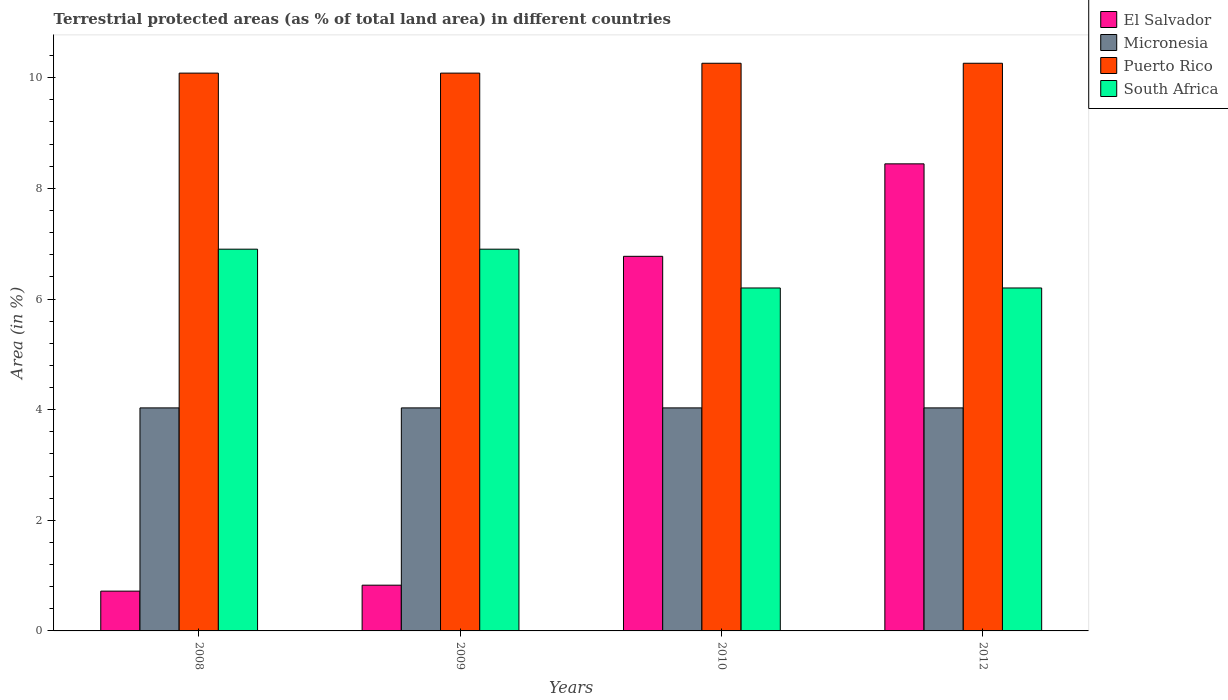How many different coloured bars are there?
Make the answer very short. 4. How many groups of bars are there?
Provide a short and direct response. 4. How many bars are there on the 2nd tick from the right?
Provide a short and direct response. 4. What is the percentage of terrestrial protected land in El Salvador in 2009?
Offer a very short reply. 0.83. Across all years, what is the maximum percentage of terrestrial protected land in Micronesia?
Give a very brief answer. 4.03. Across all years, what is the minimum percentage of terrestrial protected land in Puerto Rico?
Offer a terse response. 10.08. In which year was the percentage of terrestrial protected land in South Africa minimum?
Offer a terse response. 2010. What is the total percentage of terrestrial protected land in South Africa in the graph?
Provide a succinct answer. 26.2. What is the difference between the percentage of terrestrial protected land in Puerto Rico in 2009 and that in 2012?
Give a very brief answer. -0.18. What is the difference between the percentage of terrestrial protected land in Micronesia in 2008 and the percentage of terrestrial protected land in South Africa in 2009?
Provide a short and direct response. -2.87. What is the average percentage of terrestrial protected land in Puerto Rico per year?
Ensure brevity in your answer.  10.17. In the year 2010, what is the difference between the percentage of terrestrial protected land in El Salvador and percentage of terrestrial protected land in Puerto Rico?
Provide a short and direct response. -3.49. In how many years, is the percentage of terrestrial protected land in Micronesia greater than 3.2 %?
Keep it short and to the point. 4. What is the ratio of the percentage of terrestrial protected land in South Africa in 2008 to that in 2009?
Offer a very short reply. 1. Is the percentage of terrestrial protected land in Micronesia in 2009 less than that in 2010?
Your answer should be very brief. No. What is the difference between the highest and the second highest percentage of terrestrial protected land in Micronesia?
Offer a terse response. 0. What is the difference between the highest and the lowest percentage of terrestrial protected land in Puerto Rico?
Provide a succinct answer. 0.18. In how many years, is the percentage of terrestrial protected land in El Salvador greater than the average percentage of terrestrial protected land in El Salvador taken over all years?
Ensure brevity in your answer.  2. Is it the case that in every year, the sum of the percentage of terrestrial protected land in Puerto Rico and percentage of terrestrial protected land in El Salvador is greater than the sum of percentage of terrestrial protected land in South Africa and percentage of terrestrial protected land in Micronesia?
Keep it short and to the point. No. What does the 4th bar from the left in 2010 represents?
Offer a very short reply. South Africa. What does the 1st bar from the right in 2009 represents?
Give a very brief answer. South Africa. Is it the case that in every year, the sum of the percentage of terrestrial protected land in Puerto Rico and percentage of terrestrial protected land in Micronesia is greater than the percentage of terrestrial protected land in El Salvador?
Offer a very short reply. Yes. How many bars are there?
Ensure brevity in your answer.  16. Are all the bars in the graph horizontal?
Ensure brevity in your answer.  No. Are the values on the major ticks of Y-axis written in scientific E-notation?
Offer a terse response. No. How are the legend labels stacked?
Give a very brief answer. Vertical. What is the title of the graph?
Ensure brevity in your answer.  Terrestrial protected areas (as % of total land area) in different countries. What is the label or title of the Y-axis?
Provide a succinct answer. Area (in %). What is the Area (in %) of El Salvador in 2008?
Give a very brief answer. 0.72. What is the Area (in %) in Micronesia in 2008?
Your answer should be compact. 4.03. What is the Area (in %) in Puerto Rico in 2008?
Make the answer very short. 10.08. What is the Area (in %) in South Africa in 2008?
Offer a very short reply. 6.9. What is the Area (in %) of El Salvador in 2009?
Your answer should be compact. 0.83. What is the Area (in %) of Micronesia in 2009?
Your answer should be very brief. 4.03. What is the Area (in %) in Puerto Rico in 2009?
Your answer should be very brief. 10.08. What is the Area (in %) in South Africa in 2009?
Provide a short and direct response. 6.9. What is the Area (in %) of El Salvador in 2010?
Keep it short and to the point. 6.77. What is the Area (in %) of Micronesia in 2010?
Provide a succinct answer. 4.03. What is the Area (in %) in Puerto Rico in 2010?
Give a very brief answer. 10.26. What is the Area (in %) of South Africa in 2010?
Your answer should be very brief. 6.2. What is the Area (in %) in El Salvador in 2012?
Make the answer very short. 8.44. What is the Area (in %) of Micronesia in 2012?
Give a very brief answer. 4.03. What is the Area (in %) in Puerto Rico in 2012?
Ensure brevity in your answer.  10.26. What is the Area (in %) of South Africa in 2012?
Your response must be concise. 6.2. Across all years, what is the maximum Area (in %) of El Salvador?
Make the answer very short. 8.44. Across all years, what is the maximum Area (in %) in Micronesia?
Give a very brief answer. 4.03. Across all years, what is the maximum Area (in %) in Puerto Rico?
Give a very brief answer. 10.26. Across all years, what is the maximum Area (in %) of South Africa?
Your answer should be compact. 6.9. Across all years, what is the minimum Area (in %) in El Salvador?
Your response must be concise. 0.72. Across all years, what is the minimum Area (in %) of Micronesia?
Offer a very short reply. 4.03. Across all years, what is the minimum Area (in %) in Puerto Rico?
Keep it short and to the point. 10.08. Across all years, what is the minimum Area (in %) in South Africa?
Keep it short and to the point. 6.2. What is the total Area (in %) in El Salvador in the graph?
Offer a terse response. 16.76. What is the total Area (in %) of Micronesia in the graph?
Keep it short and to the point. 16.13. What is the total Area (in %) in Puerto Rico in the graph?
Your answer should be compact. 40.69. What is the total Area (in %) of South Africa in the graph?
Your answer should be very brief. 26.2. What is the difference between the Area (in %) of El Salvador in 2008 and that in 2009?
Provide a succinct answer. -0.11. What is the difference between the Area (in %) in Puerto Rico in 2008 and that in 2009?
Provide a short and direct response. 0. What is the difference between the Area (in %) in El Salvador in 2008 and that in 2010?
Your answer should be very brief. -6.05. What is the difference between the Area (in %) of Micronesia in 2008 and that in 2010?
Ensure brevity in your answer.  0. What is the difference between the Area (in %) in Puerto Rico in 2008 and that in 2010?
Offer a very short reply. -0.18. What is the difference between the Area (in %) in South Africa in 2008 and that in 2010?
Offer a very short reply. 0.7. What is the difference between the Area (in %) in El Salvador in 2008 and that in 2012?
Make the answer very short. -7.72. What is the difference between the Area (in %) in Micronesia in 2008 and that in 2012?
Offer a terse response. 0. What is the difference between the Area (in %) in Puerto Rico in 2008 and that in 2012?
Provide a succinct answer. -0.18. What is the difference between the Area (in %) of South Africa in 2008 and that in 2012?
Keep it short and to the point. 0.7. What is the difference between the Area (in %) in El Salvador in 2009 and that in 2010?
Your response must be concise. -5.95. What is the difference between the Area (in %) in Puerto Rico in 2009 and that in 2010?
Your response must be concise. -0.18. What is the difference between the Area (in %) in South Africa in 2009 and that in 2010?
Keep it short and to the point. 0.7. What is the difference between the Area (in %) of El Salvador in 2009 and that in 2012?
Offer a very short reply. -7.62. What is the difference between the Area (in %) of Puerto Rico in 2009 and that in 2012?
Ensure brevity in your answer.  -0.18. What is the difference between the Area (in %) of South Africa in 2009 and that in 2012?
Your answer should be compact. 0.7. What is the difference between the Area (in %) in El Salvador in 2010 and that in 2012?
Offer a very short reply. -1.67. What is the difference between the Area (in %) of Puerto Rico in 2010 and that in 2012?
Your answer should be compact. -0. What is the difference between the Area (in %) of South Africa in 2010 and that in 2012?
Keep it short and to the point. 0. What is the difference between the Area (in %) of El Salvador in 2008 and the Area (in %) of Micronesia in 2009?
Your answer should be compact. -3.31. What is the difference between the Area (in %) of El Salvador in 2008 and the Area (in %) of Puerto Rico in 2009?
Provide a succinct answer. -9.36. What is the difference between the Area (in %) of El Salvador in 2008 and the Area (in %) of South Africa in 2009?
Your answer should be compact. -6.18. What is the difference between the Area (in %) in Micronesia in 2008 and the Area (in %) in Puerto Rico in 2009?
Your response must be concise. -6.05. What is the difference between the Area (in %) in Micronesia in 2008 and the Area (in %) in South Africa in 2009?
Make the answer very short. -2.87. What is the difference between the Area (in %) of Puerto Rico in 2008 and the Area (in %) of South Africa in 2009?
Offer a very short reply. 3.18. What is the difference between the Area (in %) in El Salvador in 2008 and the Area (in %) in Micronesia in 2010?
Ensure brevity in your answer.  -3.31. What is the difference between the Area (in %) in El Salvador in 2008 and the Area (in %) in Puerto Rico in 2010?
Make the answer very short. -9.54. What is the difference between the Area (in %) in El Salvador in 2008 and the Area (in %) in South Africa in 2010?
Offer a very short reply. -5.48. What is the difference between the Area (in %) in Micronesia in 2008 and the Area (in %) in Puerto Rico in 2010?
Offer a terse response. -6.23. What is the difference between the Area (in %) in Micronesia in 2008 and the Area (in %) in South Africa in 2010?
Offer a terse response. -2.17. What is the difference between the Area (in %) of Puerto Rico in 2008 and the Area (in %) of South Africa in 2010?
Your answer should be compact. 3.88. What is the difference between the Area (in %) in El Salvador in 2008 and the Area (in %) in Micronesia in 2012?
Provide a succinct answer. -3.31. What is the difference between the Area (in %) in El Salvador in 2008 and the Area (in %) in Puerto Rico in 2012?
Your answer should be compact. -9.54. What is the difference between the Area (in %) of El Salvador in 2008 and the Area (in %) of South Africa in 2012?
Offer a very short reply. -5.48. What is the difference between the Area (in %) in Micronesia in 2008 and the Area (in %) in Puerto Rico in 2012?
Your answer should be compact. -6.23. What is the difference between the Area (in %) in Micronesia in 2008 and the Area (in %) in South Africa in 2012?
Provide a short and direct response. -2.17. What is the difference between the Area (in %) of Puerto Rico in 2008 and the Area (in %) of South Africa in 2012?
Provide a succinct answer. 3.88. What is the difference between the Area (in %) in El Salvador in 2009 and the Area (in %) in Micronesia in 2010?
Your response must be concise. -3.2. What is the difference between the Area (in %) of El Salvador in 2009 and the Area (in %) of Puerto Rico in 2010?
Offer a terse response. -9.44. What is the difference between the Area (in %) of El Salvador in 2009 and the Area (in %) of South Africa in 2010?
Keep it short and to the point. -5.37. What is the difference between the Area (in %) of Micronesia in 2009 and the Area (in %) of Puerto Rico in 2010?
Offer a very short reply. -6.23. What is the difference between the Area (in %) of Micronesia in 2009 and the Area (in %) of South Africa in 2010?
Offer a very short reply. -2.17. What is the difference between the Area (in %) of Puerto Rico in 2009 and the Area (in %) of South Africa in 2010?
Your answer should be very brief. 3.88. What is the difference between the Area (in %) in El Salvador in 2009 and the Area (in %) in Micronesia in 2012?
Make the answer very short. -3.2. What is the difference between the Area (in %) of El Salvador in 2009 and the Area (in %) of Puerto Rico in 2012?
Give a very brief answer. -9.44. What is the difference between the Area (in %) of El Salvador in 2009 and the Area (in %) of South Africa in 2012?
Give a very brief answer. -5.37. What is the difference between the Area (in %) in Micronesia in 2009 and the Area (in %) in Puerto Rico in 2012?
Make the answer very short. -6.23. What is the difference between the Area (in %) in Micronesia in 2009 and the Area (in %) in South Africa in 2012?
Keep it short and to the point. -2.17. What is the difference between the Area (in %) of Puerto Rico in 2009 and the Area (in %) of South Africa in 2012?
Make the answer very short. 3.88. What is the difference between the Area (in %) in El Salvador in 2010 and the Area (in %) in Micronesia in 2012?
Your answer should be compact. 2.74. What is the difference between the Area (in %) of El Salvador in 2010 and the Area (in %) of Puerto Rico in 2012?
Your answer should be compact. -3.49. What is the difference between the Area (in %) in El Salvador in 2010 and the Area (in %) in South Africa in 2012?
Make the answer very short. 0.57. What is the difference between the Area (in %) of Micronesia in 2010 and the Area (in %) of Puerto Rico in 2012?
Provide a short and direct response. -6.23. What is the difference between the Area (in %) of Micronesia in 2010 and the Area (in %) of South Africa in 2012?
Make the answer very short. -2.17. What is the difference between the Area (in %) of Puerto Rico in 2010 and the Area (in %) of South Africa in 2012?
Offer a terse response. 4.06. What is the average Area (in %) in El Salvador per year?
Offer a terse response. 4.19. What is the average Area (in %) in Micronesia per year?
Make the answer very short. 4.03. What is the average Area (in %) of Puerto Rico per year?
Provide a short and direct response. 10.17. What is the average Area (in %) in South Africa per year?
Give a very brief answer. 6.55. In the year 2008, what is the difference between the Area (in %) in El Salvador and Area (in %) in Micronesia?
Your response must be concise. -3.31. In the year 2008, what is the difference between the Area (in %) of El Salvador and Area (in %) of Puerto Rico?
Ensure brevity in your answer.  -9.36. In the year 2008, what is the difference between the Area (in %) in El Salvador and Area (in %) in South Africa?
Offer a very short reply. -6.18. In the year 2008, what is the difference between the Area (in %) of Micronesia and Area (in %) of Puerto Rico?
Your answer should be very brief. -6.05. In the year 2008, what is the difference between the Area (in %) in Micronesia and Area (in %) in South Africa?
Your answer should be very brief. -2.87. In the year 2008, what is the difference between the Area (in %) in Puerto Rico and Area (in %) in South Africa?
Keep it short and to the point. 3.18. In the year 2009, what is the difference between the Area (in %) of El Salvador and Area (in %) of Micronesia?
Your answer should be compact. -3.2. In the year 2009, what is the difference between the Area (in %) in El Salvador and Area (in %) in Puerto Rico?
Your answer should be very brief. -9.26. In the year 2009, what is the difference between the Area (in %) in El Salvador and Area (in %) in South Africa?
Give a very brief answer. -6.07. In the year 2009, what is the difference between the Area (in %) of Micronesia and Area (in %) of Puerto Rico?
Provide a succinct answer. -6.05. In the year 2009, what is the difference between the Area (in %) of Micronesia and Area (in %) of South Africa?
Ensure brevity in your answer.  -2.87. In the year 2009, what is the difference between the Area (in %) in Puerto Rico and Area (in %) in South Africa?
Your answer should be very brief. 3.18. In the year 2010, what is the difference between the Area (in %) in El Salvador and Area (in %) in Micronesia?
Your answer should be compact. 2.74. In the year 2010, what is the difference between the Area (in %) in El Salvador and Area (in %) in Puerto Rico?
Give a very brief answer. -3.49. In the year 2010, what is the difference between the Area (in %) in El Salvador and Area (in %) in South Africa?
Provide a short and direct response. 0.57. In the year 2010, what is the difference between the Area (in %) of Micronesia and Area (in %) of Puerto Rico?
Your answer should be compact. -6.23. In the year 2010, what is the difference between the Area (in %) of Micronesia and Area (in %) of South Africa?
Make the answer very short. -2.17. In the year 2010, what is the difference between the Area (in %) in Puerto Rico and Area (in %) in South Africa?
Keep it short and to the point. 4.06. In the year 2012, what is the difference between the Area (in %) in El Salvador and Area (in %) in Micronesia?
Give a very brief answer. 4.41. In the year 2012, what is the difference between the Area (in %) in El Salvador and Area (in %) in Puerto Rico?
Your response must be concise. -1.82. In the year 2012, what is the difference between the Area (in %) of El Salvador and Area (in %) of South Africa?
Keep it short and to the point. 2.24. In the year 2012, what is the difference between the Area (in %) of Micronesia and Area (in %) of Puerto Rico?
Offer a very short reply. -6.23. In the year 2012, what is the difference between the Area (in %) of Micronesia and Area (in %) of South Africa?
Make the answer very short. -2.17. In the year 2012, what is the difference between the Area (in %) in Puerto Rico and Area (in %) in South Africa?
Ensure brevity in your answer.  4.06. What is the ratio of the Area (in %) in El Salvador in 2008 to that in 2009?
Provide a short and direct response. 0.87. What is the ratio of the Area (in %) of Micronesia in 2008 to that in 2009?
Keep it short and to the point. 1. What is the ratio of the Area (in %) of Puerto Rico in 2008 to that in 2009?
Give a very brief answer. 1. What is the ratio of the Area (in %) in El Salvador in 2008 to that in 2010?
Your answer should be very brief. 0.11. What is the ratio of the Area (in %) in Micronesia in 2008 to that in 2010?
Offer a very short reply. 1. What is the ratio of the Area (in %) of Puerto Rico in 2008 to that in 2010?
Provide a succinct answer. 0.98. What is the ratio of the Area (in %) of South Africa in 2008 to that in 2010?
Your answer should be very brief. 1.11. What is the ratio of the Area (in %) of El Salvador in 2008 to that in 2012?
Offer a very short reply. 0.09. What is the ratio of the Area (in %) in Micronesia in 2008 to that in 2012?
Provide a succinct answer. 1. What is the ratio of the Area (in %) in Puerto Rico in 2008 to that in 2012?
Your answer should be compact. 0.98. What is the ratio of the Area (in %) of South Africa in 2008 to that in 2012?
Provide a succinct answer. 1.11. What is the ratio of the Area (in %) of El Salvador in 2009 to that in 2010?
Keep it short and to the point. 0.12. What is the ratio of the Area (in %) of Puerto Rico in 2009 to that in 2010?
Give a very brief answer. 0.98. What is the ratio of the Area (in %) of South Africa in 2009 to that in 2010?
Your answer should be compact. 1.11. What is the ratio of the Area (in %) of El Salvador in 2009 to that in 2012?
Your answer should be very brief. 0.1. What is the ratio of the Area (in %) of Micronesia in 2009 to that in 2012?
Keep it short and to the point. 1. What is the ratio of the Area (in %) of Puerto Rico in 2009 to that in 2012?
Keep it short and to the point. 0.98. What is the ratio of the Area (in %) in South Africa in 2009 to that in 2012?
Offer a terse response. 1.11. What is the ratio of the Area (in %) in El Salvador in 2010 to that in 2012?
Your answer should be very brief. 0.8. What is the ratio of the Area (in %) in Puerto Rico in 2010 to that in 2012?
Make the answer very short. 1. What is the ratio of the Area (in %) in South Africa in 2010 to that in 2012?
Ensure brevity in your answer.  1. What is the difference between the highest and the second highest Area (in %) of El Salvador?
Keep it short and to the point. 1.67. What is the difference between the highest and the lowest Area (in %) of El Salvador?
Keep it short and to the point. 7.72. What is the difference between the highest and the lowest Area (in %) of Puerto Rico?
Give a very brief answer. 0.18. What is the difference between the highest and the lowest Area (in %) in South Africa?
Your answer should be very brief. 0.7. 